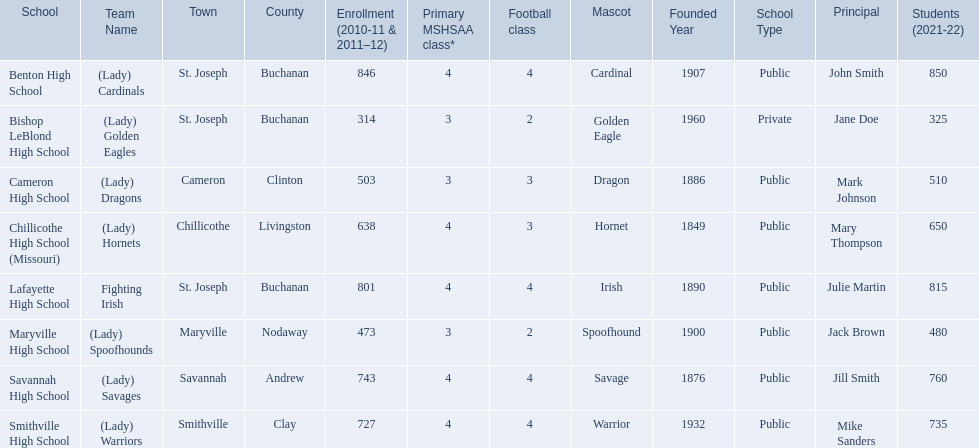What were the schools enrolled in 2010-2011 Benton High School, Bishop LeBlond High School, Cameron High School, Chillicothe High School (Missouri), Lafayette High School, Maryville High School, Savannah High School, Smithville High School. How many were enrolled in each? 846, 314, 503, 638, 801, 473, 743, 727. Which is the lowest number? 314. Which school had this number of students? Bishop LeBlond High School. 